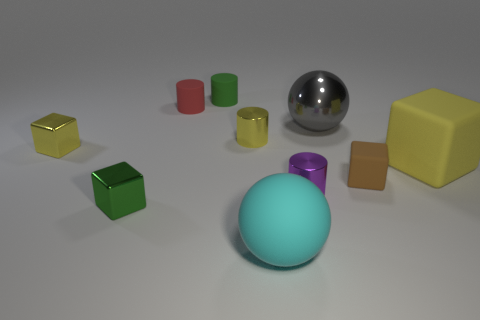Is the large block the same color as the shiny sphere?
Offer a terse response. No. What number of yellow objects have the same size as the purple thing?
Keep it short and to the point. 2. What material is the cyan thing?
Offer a terse response. Rubber. How big is the yellow thing that is on the left side of the red thing?
Your answer should be compact. Small. How many tiny red objects are the same shape as the cyan matte object?
Offer a terse response. 0. There is a small red object that is the same material as the brown cube; what is its shape?
Your response must be concise. Cylinder. What number of brown things are either cylinders or small objects?
Give a very brief answer. 1. There is a large shiny sphere; are there any yellow things to the right of it?
Provide a short and direct response. Yes. Is the shape of the small green object in front of the yellow matte block the same as the red thing behind the cyan ball?
Make the answer very short. No. What is the material of the red object that is the same shape as the green matte object?
Offer a very short reply. Rubber. 